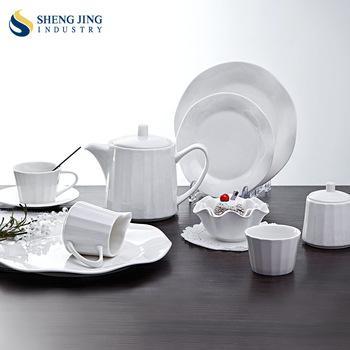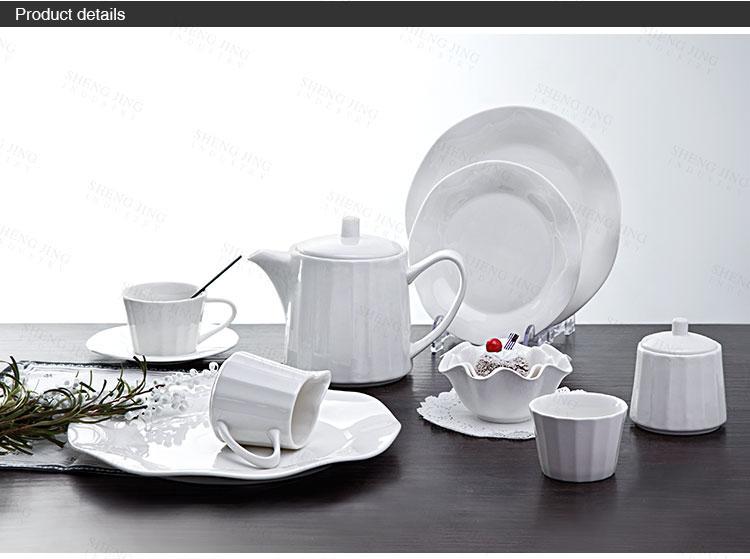The first image is the image on the left, the second image is the image on the right. Given the left and right images, does the statement "There are plates stacked together in exactly one image." hold true? Answer yes or no. No. 